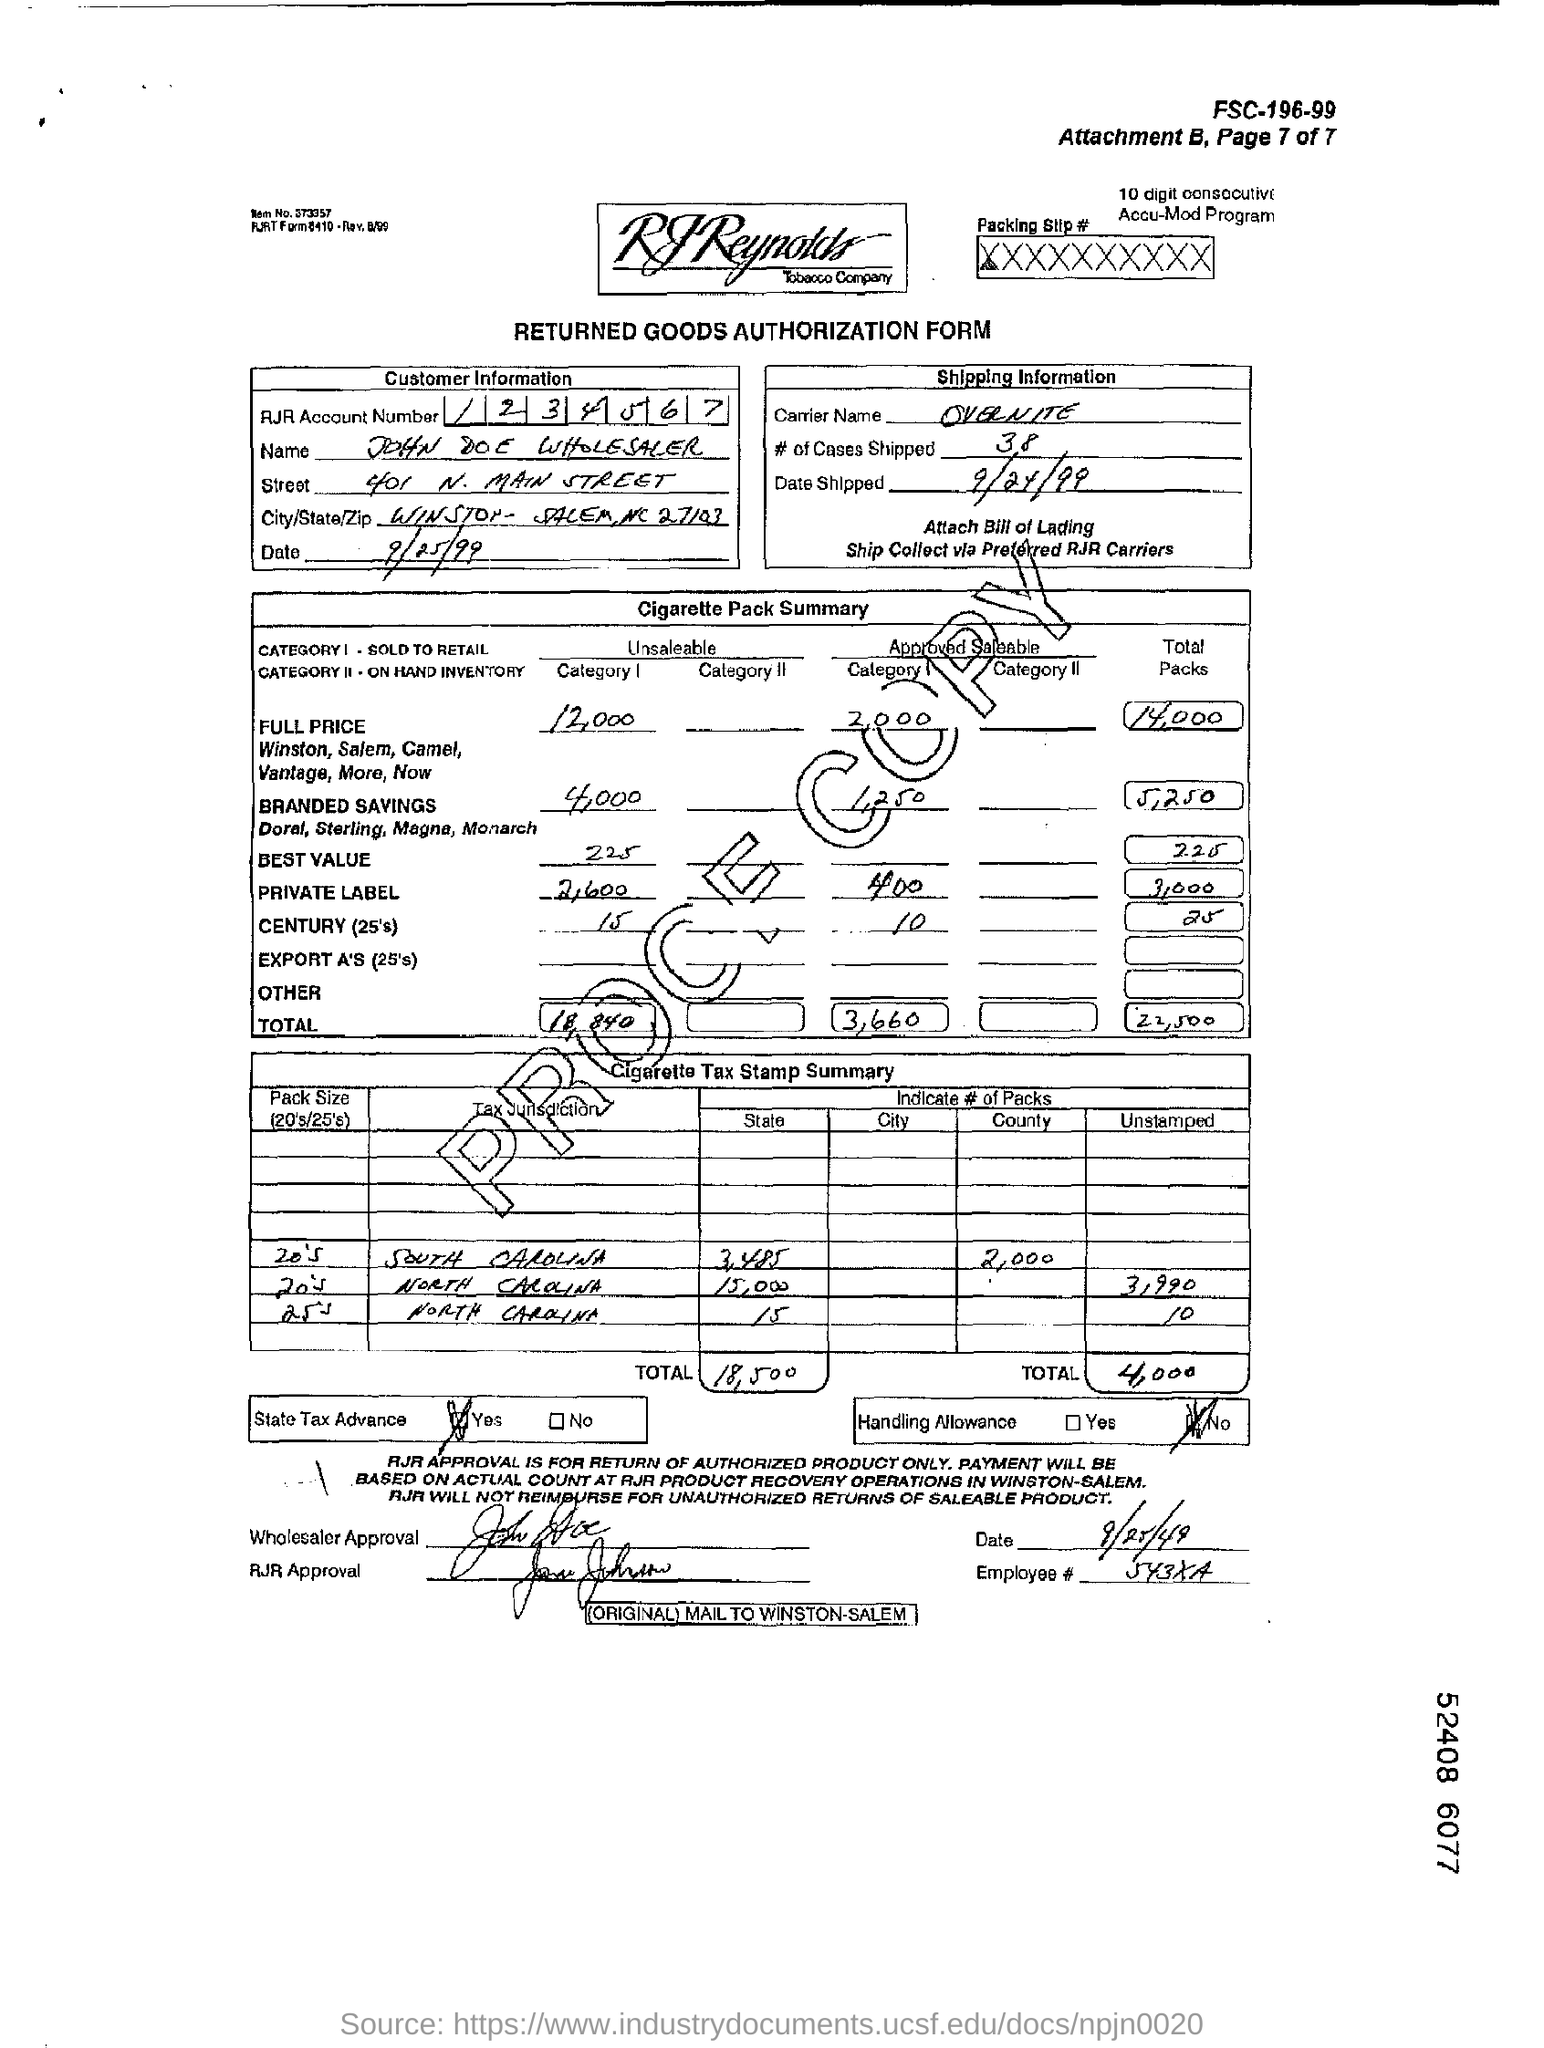What is the RJR Account Number mentioned?
Keep it short and to the point. 1234567. What is the carrier name?
Offer a terse response. OVERNITE. How many cases were shipped?
Provide a succinct answer. 38. 